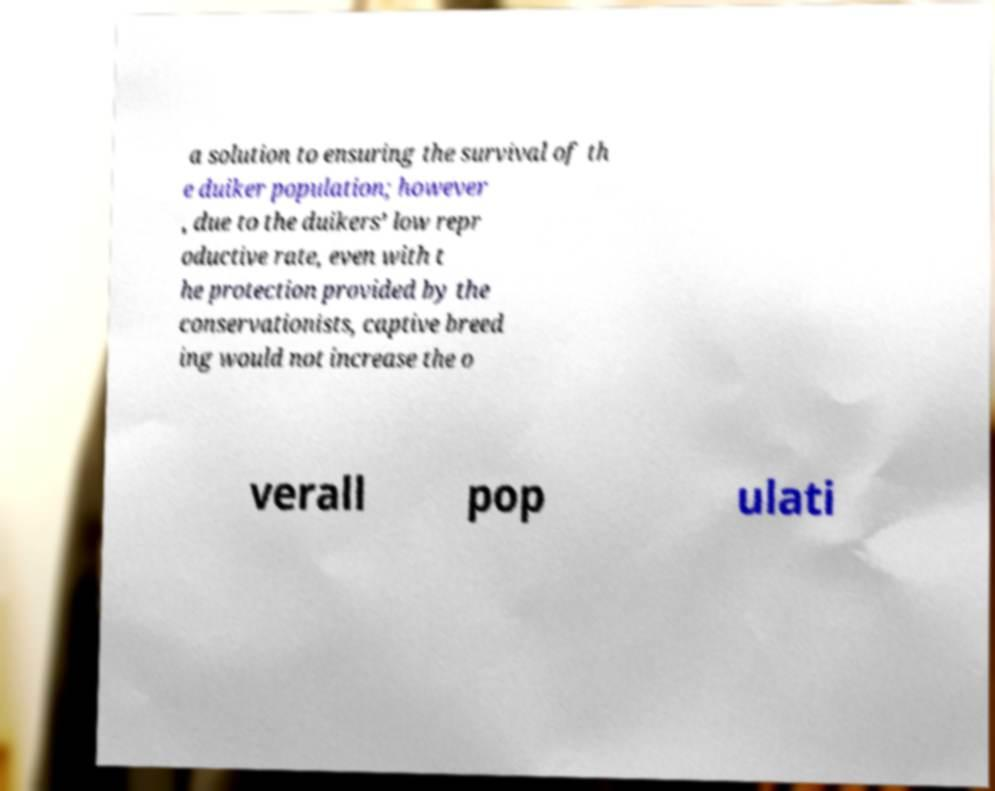I need the written content from this picture converted into text. Can you do that? a solution to ensuring the survival of th e duiker population; however , due to the duikers’ low repr oductive rate, even with t he protection provided by the conservationists, captive breed ing would not increase the o verall pop ulati 